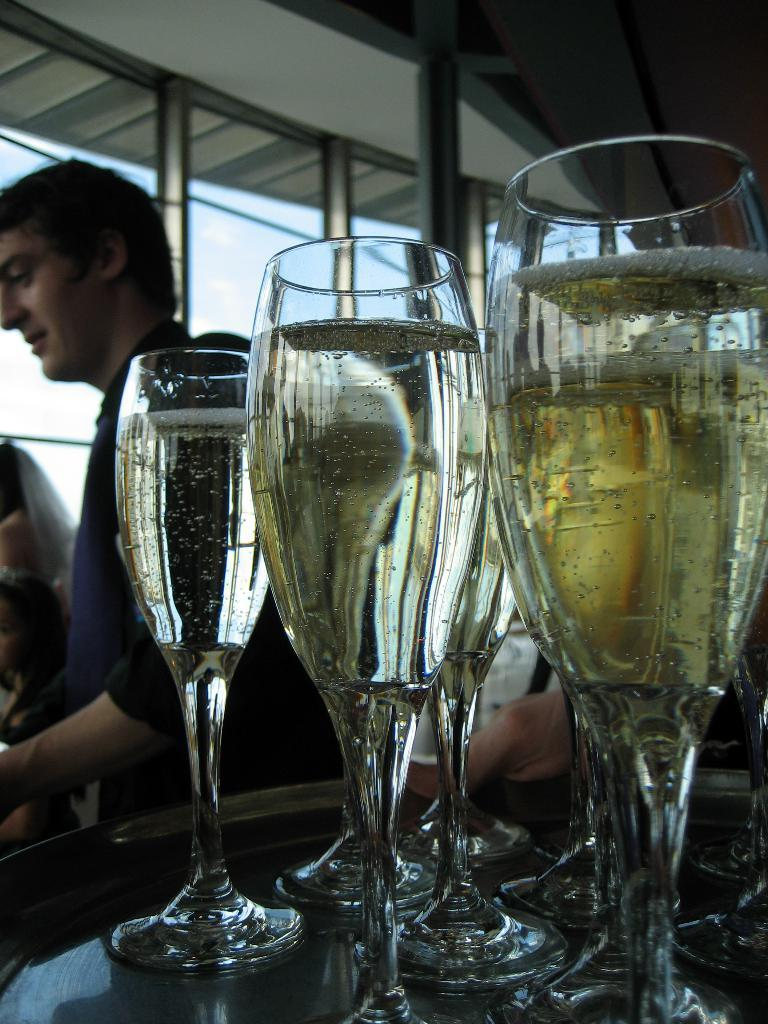What is the person's hand holding in the image? The person's hand is holding a tray in the image. What is on the tray that the person is holding? The tray contains wine glasses. What can be seen in the background of the image? There are people and walls visible in the background of the image. What type of food is being served on the person's hand in the image? There is no food being served on the person's hand in the image; it is a tray with wine glasses. 